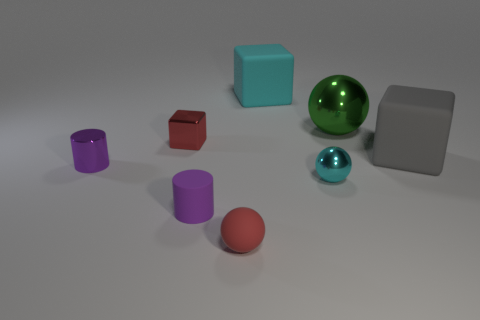Subtract all small red cubes. How many cubes are left? 2 Add 1 gray rubber cylinders. How many objects exist? 9 Subtract all green blocks. Subtract all green cylinders. How many blocks are left? 3 Subtract all cubes. How many objects are left? 5 Add 3 tiny things. How many tiny things are left? 8 Add 2 tiny red things. How many tiny red things exist? 4 Subtract 1 red spheres. How many objects are left? 7 Subtract all big brown shiny cubes. Subtract all tiny red things. How many objects are left? 6 